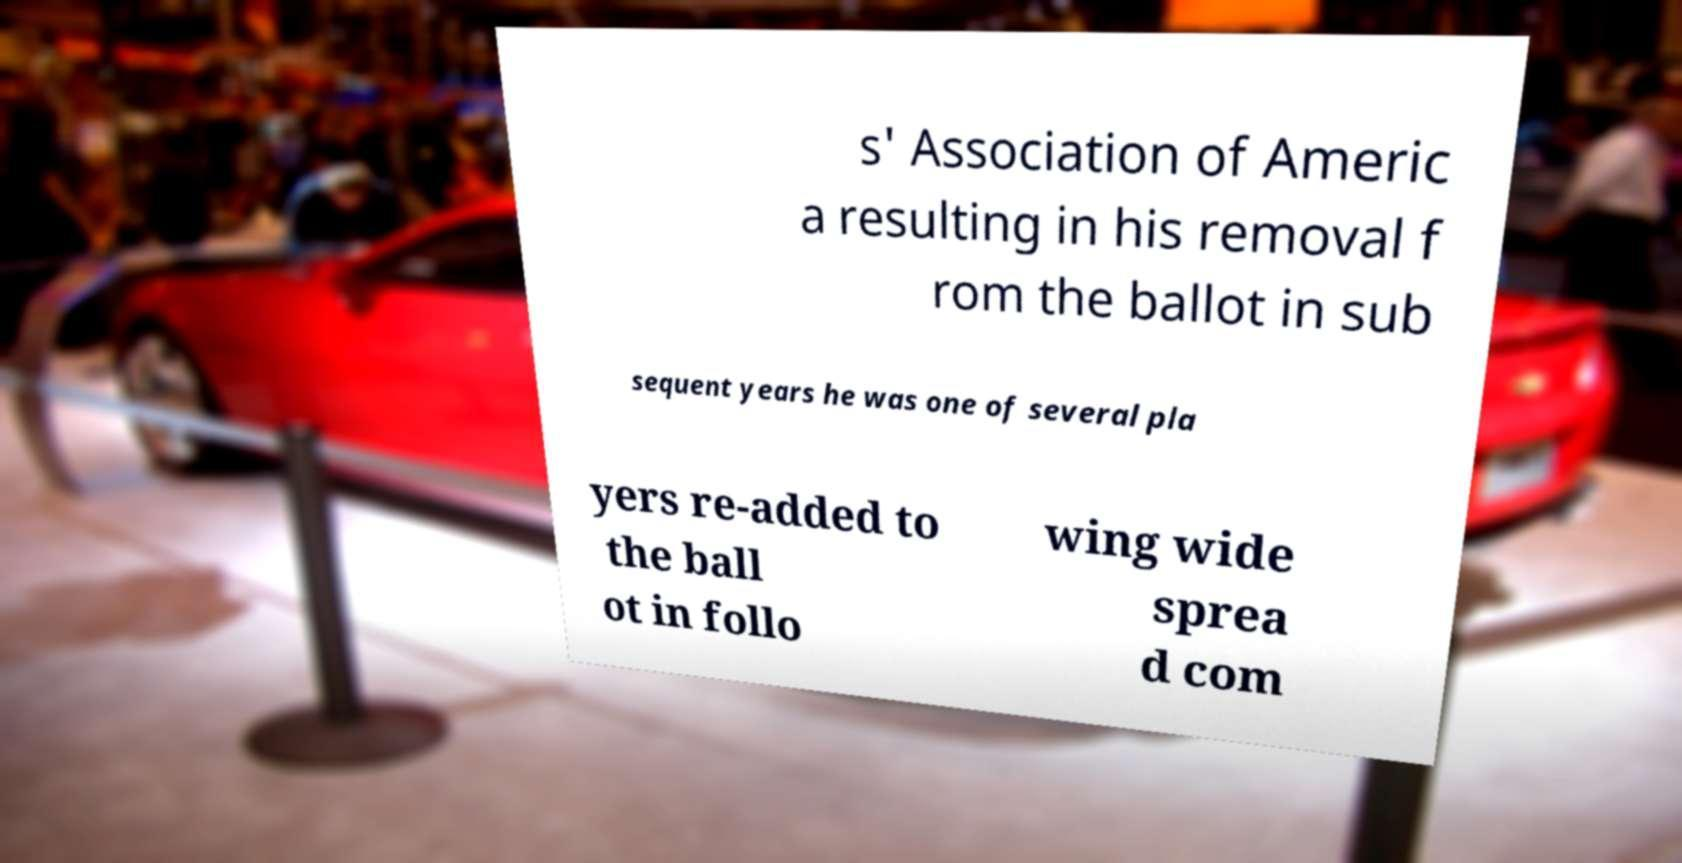Can you accurately transcribe the text from the provided image for me? s' Association of Americ a resulting in his removal f rom the ballot in sub sequent years he was one of several pla yers re-added to the ball ot in follo wing wide sprea d com 